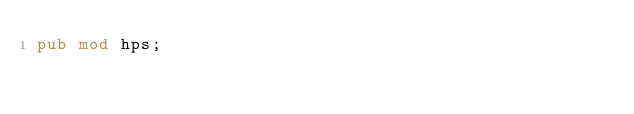Convert code to text. <code><loc_0><loc_0><loc_500><loc_500><_Rust_>pub mod hps;
</code> 